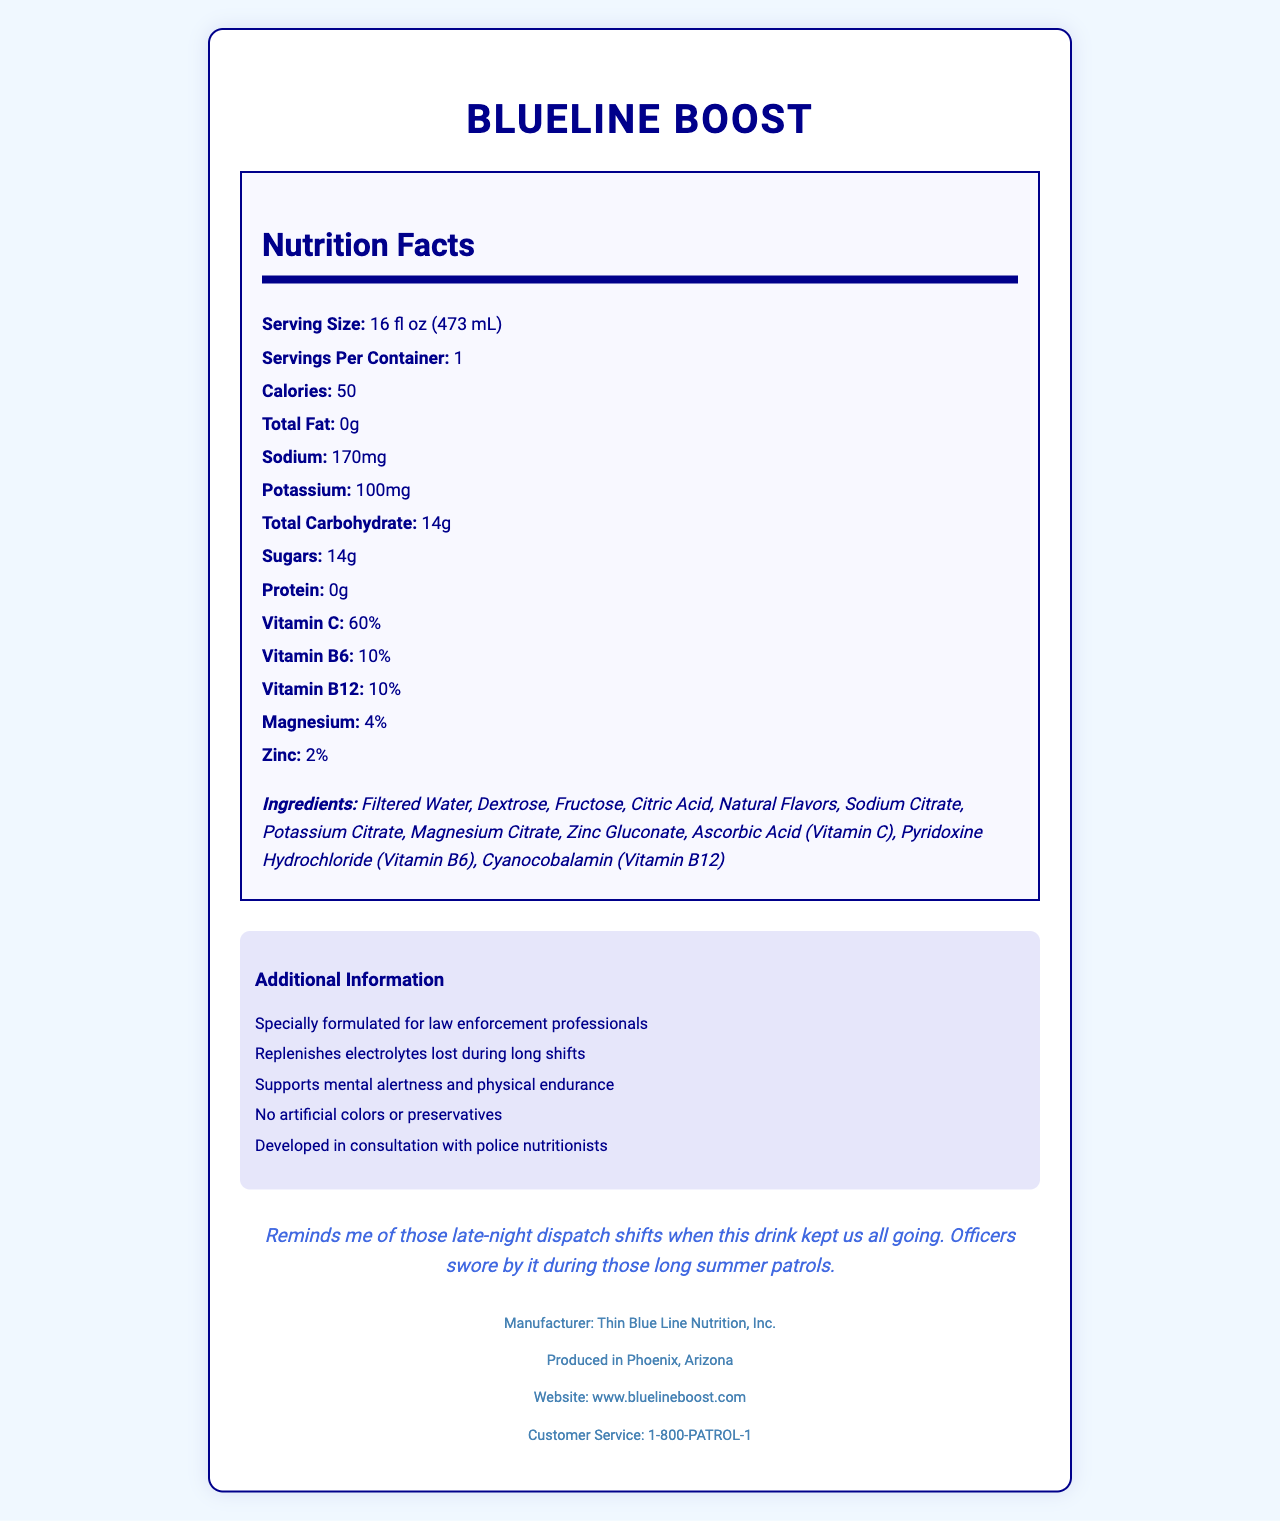what is the serving size of BlueLine Boost? The serving size is clearly stated as "16 fl oz (473 mL)" in the Nutrition Facts section of the document.
Answer: 16 fl oz (473 mL) how many calories are in one serving of BlueLine Boost? According to the Nutrition Facts, each serving contains 50 calories.
Answer: 50 calories what percentage of Vitamin C is in BlueLine Boost? The Nutrition Facts section shows that BlueLine Boost contains 60% of the daily recommended value for Vitamin C.
Answer: 60% what is the sodium content per serving? The sodium content per serving is listed as 170mg in the Nutrition Facts section.
Answer: 170mg what are the main ingredients in BlueLine Boost? The document lists all the ingredients under the Ingredients section in the Nutrition Facts label.
Answer: Filtered Water, Dextrose, Fructose, Citric Acid, Natural Flavors, Sodium Citrate, Potassium Citrate, Magnesium Citrate, Zinc Gluconate, Ascorbic Acid (Vitamin C), Pyridoxine Hydrochloride (Vitamin B6), Cyanocobalamin (Vitamin B12) which company manufactures BlueLine Boost? A. Law Enforcement Nutrition, Inc. B. Health Patrol Nutrition, Inc. C. Thin Blue Line Nutrition, Inc. D. BlueLine Beverage Co. The footer of the document states that the manufacturer is "Thin Blue Line Nutrition, Inc."
Answer: C where is BlueLine Boost produced? A. Los Angeles, California B. Phoenix, Arizona C. Chicago, Illinois D. Dallas, Texas The footer of the document indicates that BlueLine Boost is produced in Phoenix, Arizona.
Answer: B is BlueLine Boost artificially colored? The additional information section specifically states that it has "No artificial colors or preservatives."
Answer: No does BlueLine Boost contain protein? The Nutrition Facts section shows that the protein content is "0g," indicating that it does not contain protein.
Answer: No summarize the main features of BlueLine Boost. This summary captures all the essential details from the document, including the product's purpose, nutritional content, features, and manufacturer.
Answer: BlueLine Boost is an electrolyte-rich sports drink designed for law enforcement professionals, providing essential vitamins and minerals without artificial colors or preservatives. Each 16 fl oz serving contains 50 calories, 170mg of sodium, 100mg of potassium, and 14g of sugars. It also includes significant amounts of Vitamin C (60%) and smaller amounts of other vitamins and minerals. It supports mental alertness and physical endurance and is produced by Thin Blue Line Nutrition, Inc. in Phoenix, Arizona. what are the total carbohydrate content and sugars in BlueLine Boost? Show as one value. The Nutrition Facts state that the total carbohydrate content is 14g, which is all from sugars (14g).
Answer: 14g how is BlueLine Boost formulated to support law enforcement professionals? According to the additional information section, BlueLine Boost is specially formulated to replenish electrolytes lost during long shifts and to support mental alertness and physical endurance.
Answer: Replenishes electrolytes, supports mental alertness and physical endurance what is BlueLine Boost flavored as? The document states that the flavor of BlueLine Boost is "Citrus Surge."
Answer: Citrus Surge how much potassium is in one serving of BlueLine Boost? The Nutrition Facts section indicates that one serving contains 100mg of potassium.
Answer: 100mg what is the customer service phone number for BlueLine Boost? The footer of the document lists the customer service phone number as "1-800-PATROL-1."
Answer: 1-800-PATROL-1 is BlueLine Boost formulated for athletes? The document specifically mentions that BlueLine Boost is formulated for law enforcement professionals, but it does not provide explicit information about its suitability for athletes.
Answer: Cannot be determined what is the percentage of Vitamin B12 in BlueLine Boost? The Nutrition Facts section indicates that BlueLine Boost contains 10% of the daily recommended value for Vitamin B12.
Answer: 10% 